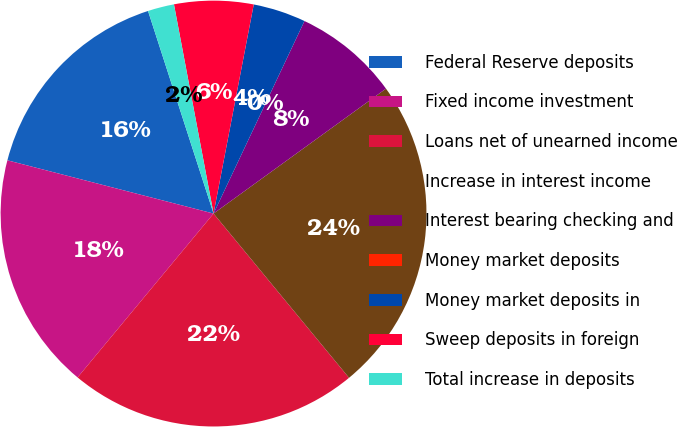Convert chart. <chart><loc_0><loc_0><loc_500><loc_500><pie_chart><fcel>Federal Reserve deposits<fcel>Fixed income investment<fcel>Loans net of unearned income<fcel>Increase in interest income<fcel>Interest bearing checking and<fcel>Money market deposits<fcel>Money market deposits in<fcel>Sweep deposits in foreign<fcel>Total increase in deposits<nl><fcel>16.0%<fcel>18.0%<fcel>22.0%<fcel>24.0%<fcel>8.0%<fcel>0.0%<fcel>4.0%<fcel>6.0%<fcel>2.0%<nl></chart> 